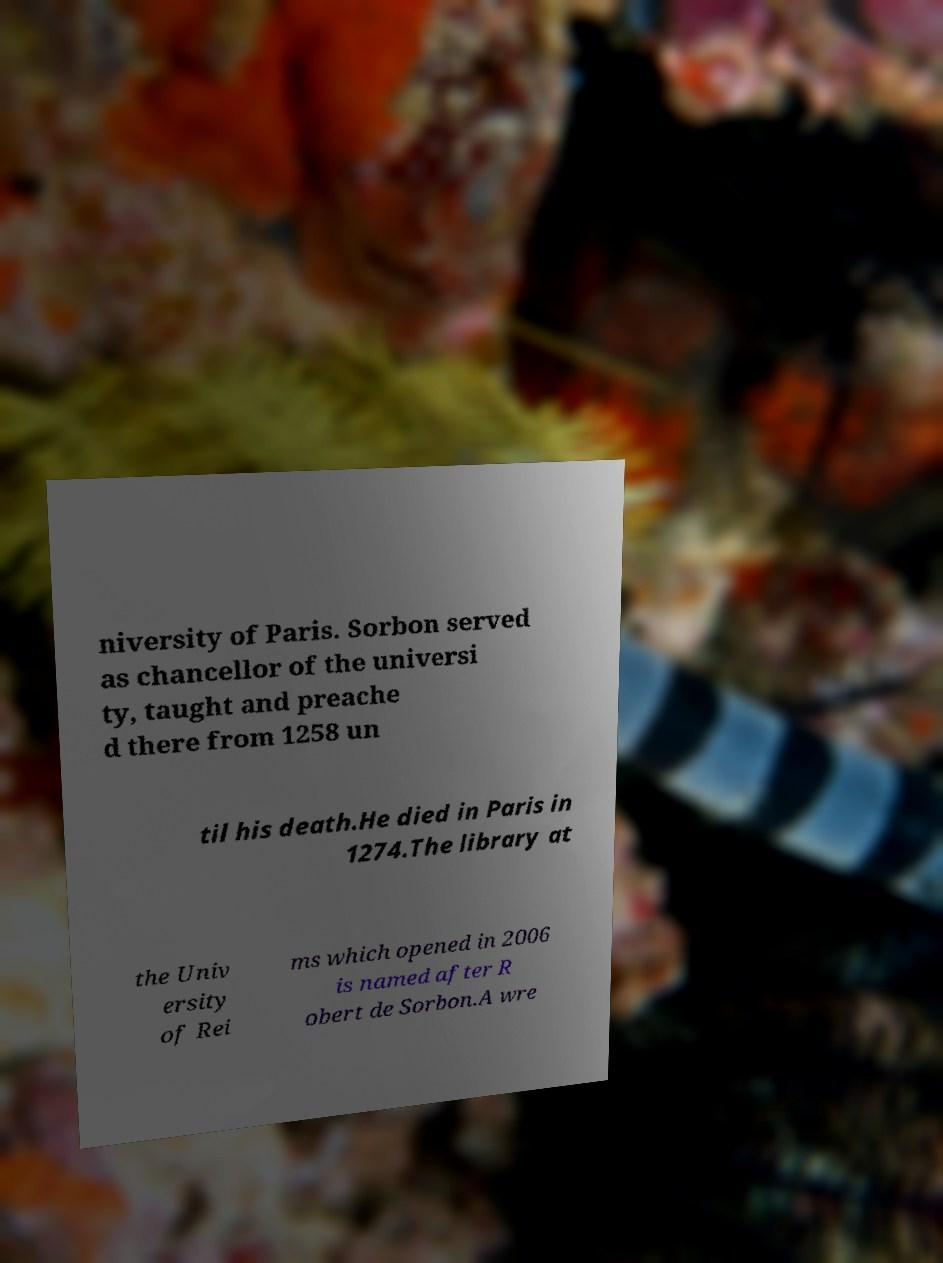Can you read and provide the text displayed in the image?This photo seems to have some interesting text. Can you extract and type it out for me? niversity of Paris. Sorbon served as chancellor of the universi ty, taught and preache d there from 1258 un til his death.He died in Paris in 1274.The library at the Univ ersity of Rei ms which opened in 2006 is named after R obert de Sorbon.A wre 